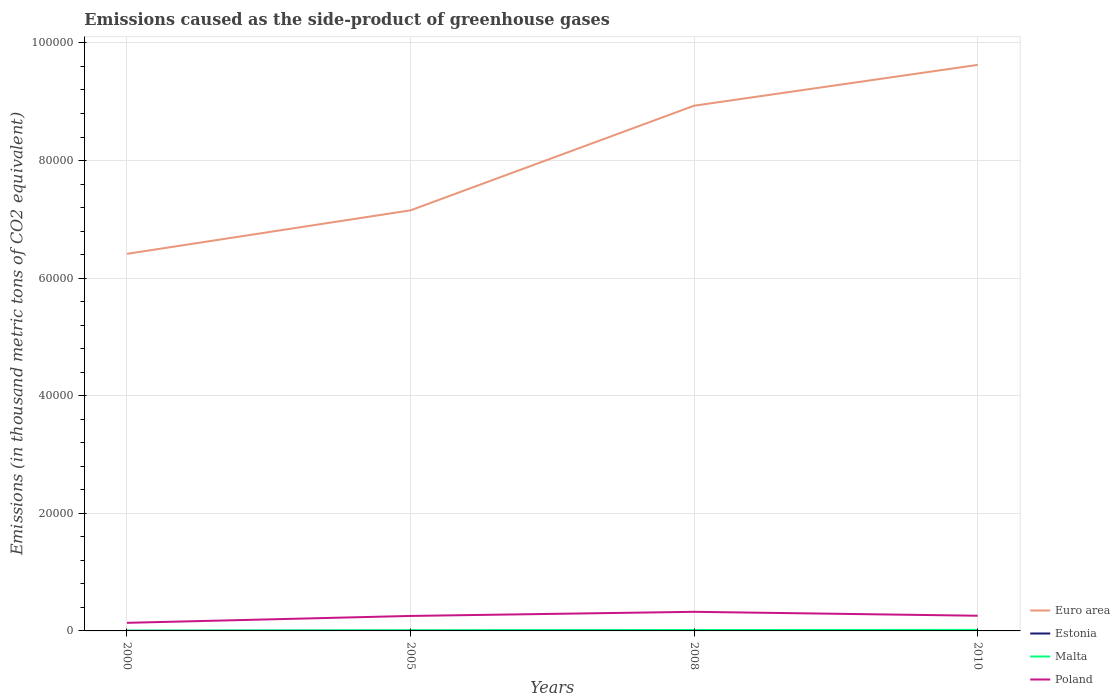How many different coloured lines are there?
Your answer should be very brief. 4. Does the line corresponding to Estonia intersect with the line corresponding to Malta?
Make the answer very short. No. Across all years, what is the maximum emissions caused as the side-product of greenhouse gases in Euro area?
Your answer should be very brief. 6.41e+04. What is the total emissions caused as the side-product of greenhouse gases in Estonia in the graph?
Your answer should be very brief. -13.9. What is the difference between the highest and the second highest emissions caused as the side-product of greenhouse gases in Malta?
Ensure brevity in your answer.  123. How many years are there in the graph?
Your response must be concise. 4. What is the difference between two consecutive major ticks on the Y-axis?
Provide a succinct answer. 2.00e+04. Are the values on the major ticks of Y-axis written in scientific E-notation?
Offer a terse response. No. Does the graph contain any zero values?
Give a very brief answer. No. Does the graph contain grids?
Your response must be concise. Yes. Where does the legend appear in the graph?
Ensure brevity in your answer.  Bottom right. How many legend labels are there?
Your response must be concise. 4. What is the title of the graph?
Provide a succinct answer. Emissions caused as the side-product of greenhouse gases. Does "Heavily indebted poor countries" appear as one of the legend labels in the graph?
Give a very brief answer. No. What is the label or title of the Y-axis?
Your response must be concise. Emissions (in thousand metric tons of CO2 equivalent). What is the Emissions (in thousand metric tons of CO2 equivalent) in Euro area in 2000?
Ensure brevity in your answer.  6.41e+04. What is the Emissions (in thousand metric tons of CO2 equivalent) of Poland in 2000?
Offer a terse response. 1376.3. What is the Emissions (in thousand metric tons of CO2 equivalent) of Euro area in 2005?
Your response must be concise. 7.15e+04. What is the Emissions (in thousand metric tons of CO2 equivalent) of Estonia in 2005?
Provide a short and direct response. 39.4. What is the Emissions (in thousand metric tons of CO2 equivalent) of Malta in 2005?
Offer a very short reply. 114.2. What is the Emissions (in thousand metric tons of CO2 equivalent) of Poland in 2005?
Ensure brevity in your answer.  2547.9. What is the Emissions (in thousand metric tons of CO2 equivalent) of Euro area in 2008?
Provide a short and direct response. 8.93e+04. What is the Emissions (in thousand metric tons of CO2 equivalent) in Estonia in 2008?
Your response must be concise. 53.3. What is the Emissions (in thousand metric tons of CO2 equivalent) of Malta in 2008?
Give a very brief answer. 153.2. What is the Emissions (in thousand metric tons of CO2 equivalent) in Poland in 2008?
Your answer should be compact. 3249.8. What is the Emissions (in thousand metric tons of CO2 equivalent) in Euro area in 2010?
Your response must be concise. 9.63e+04. What is the Emissions (in thousand metric tons of CO2 equivalent) of Malta in 2010?
Keep it short and to the point. 173. What is the Emissions (in thousand metric tons of CO2 equivalent) of Poland in 2010?
Offer a terse response. 2582. Across all years, what is the maximum Emissions (in thousand metric tons of CO2 equivalent) in Euro area?
Your answer should be compact. 9.63e+04. Across all years, what is the maximum Emissions (in thousand metric tons of CO2 equivalent) in Malta?
Ensure brevity in your answer.  173. Across all years, what is the maximum Emissions (in thousand metric tons of CO2 equivalent) in Poland?
Provide a succinct answer. 3249.8. Across all years, what is the minimum Emissions (in thousand metric tons of CO2 equivalent) of Euro area?
Your answer should be compact. 6.41e+04. Across all years, what is the minimum Emissions (in thousand metric tons of CO2 equivalent) of Estonia?
Make the answer very short. 13.3. Across all years, what is the minimum Emissions (in thousand metric tons of CO2 equivalent) of Malta?
Ensure brevity in your answer.  50. Across all years, what is the minimum Emissions (in thousand metric tons of CO2 equivalent) in Poland?
Make the answer very short. 1376.3. What is the total Emissions (in thousand metric tons of CO2 equivalent) of Euro area in the graph?
Give a very brief answer. 3.21e+05. What is the total Emissions (in thousand metric tons of CO2 equivalent) of Estonia in the graph?
Give a very brief answer. 169. What is the total Emissions (in thousand metric tons of CO2 equivalent) in Malta in the graph?
Keep it short and to the point. 490.4. What is the total Emissions (in thousand metric tons of CO2 equivalent) in Poland in the graph?
Provide a succinct answer. 9756. What is the difference between the Emissions (in thousand metric tons of CO2 equivalent) in Euro area in 2000 and that in 2005?
Ensure brevity in your answer.  -7401.3. What is the difference between the Emissions (in thousand metric tons of CO2 equivalent) in Estonia in 2000 and that in 2005?
Keep it short and to the point. -26.1. What is the difference between the Emissions (in thousand metric tons of CO2 equivalent) of Malta in 2000 and that in 2005?
Provide a succinct answer. -64.2. What is the difference between the Emissions (in thousand metric tons of CO2 equivalent) of Poland in 2000 and that in 2005?
Your answer should be compact. -1171.6. What is the difference between the Emissions (in thousand metric tons of CO2 equivalent) in Euro area in 2000 and that in 2008?
Your response must be concise. -2.52e+04. What is the difference between the Emissions (in thousand metric tons of CO2 equivalent) in Estonia in 2000 and that in 2008?
Keep it short and to the point. -40. What is the difference between the Emissions (in thousand metric tons of CO2 equivalent) in Malta in 2000 and that in 2008?
Ensure brevity in your answer.  -103.2. What is the difference between the Emissions (in thousand metric tons of CO2 equivalent) of Poland in 2000 and that in 2008?
Ensure brevity in your answer.  -1873.5. What is the difference between the Emissions (in thousand metric tons of CO2 equivalent) in Euro area in 2000 and that in 2010?
Provide a succinct answer. -3.21e+04. What is the difference between the Emissions (in thousand metric tons of CO2 equivalent) in Estonia in 2000 and that in 2010?
Ensure brevity in your answer.  -49.7. What is the difference between the Emissions (in thousand metric tons of CO2 equivalent) of Malta in 2000 and that in 2010?
Make the answer very short. -123. What is the difference between the Emissions (in thousand metric tons of CO2 equivalent) of Poland in 2000 and that in 2010?
Ensure brevity in your answer.  -1205.7. What is the difference between the Emissions (in thousand metric tons of CO2 equivalent) of Euro area in 2005 and that in 2008?
Make the answer very short. -1.78e+04. What is the difference between the Emissions (in thousand metric tons of CO2 equivalent) of Estonia in 2005 and that in 2008?
Keep it short and to the point. -13.9. What is the difference between the Emissions (in thousand metric tons of CO2 equivalent) of Malta in 2005 and that in 2008?
Provide a short and direct response. -39. What is the difference between the Emissions (in thousand metric tons of CO2 equivalent) in Poland in 2005 and that in 2008?
Offer a terse response. -701.9. What is the difference between the Emissions (in thousand metric tons of CO2 equivalent) of Euro area in 2005 and that in 2010?
Keep it short and to the point. -2.47e+04. What is the difference between the Emissions (in thousand metric tons of CO2 equivalent) of Estonia in 2005 and that in 2010?
Keep it short and to the point. -23.6. What is the difference between the Emissions (in thousand metric tons of CO2 equivalent) of Malta in 2005 and that in 2010?
Keep it short and to the point. -58.8. What is the difference between the Emissions (in thousand metric tons of CO2 equivalent) in Poland in 2005 and that in 2010?
Keep it short and to the point. -34.1. What is the difference between the Emissions (in thousand metric tons of CO2 equivalent) of Euro area in 2008 and that in 2010?
Ensure brevity in your answer.  -6944.7. What is the difference between the Emissions (in thousand metric tons of CO2 equivalent) of Malta in 2008 and that in 2010?
Make the answer very short. -19.8. What is the difference between the Emissions (in thousand metric tons of CO2 equivalent) of Poland in 2008 and that in 2010?
Provide a succinct answer. 667.8. What is the difference between the Emissions (in thousand metric tons of CO2 equivalent) in Euro area in 2000 and the Emissions (in thousand metric tons of CO2 equivalent) in Estonia in 2005?
Your response must be concise. 6.41e+04. What is the difference between the Emissions (in thousand metric tons of CO2 equivalent) in Euro area in 2000 and the Emissions (in thousand metric tons of CO2 equivalent) in Malta in 2005?
Your answer should be compact. 6.40e+04. What is the difference between the Emissions (in thousand metric tons of CO2 equivalent) in Euro area in 2000 and the Emissions (in thousand metric tons of CO2 equivalent) in Poland in 2005?
Your answer should be very brief. 6.16e+04. What is the difference between the Emissions (in thousand metric tons of CO2 equivalent) of Estonia in 2000 and the Emissions (in thousand metric tons of CO2 equivalent) of Malta in 2005?
Ensure brevity in your answer.  -100.9. What is the difference between the Emissions (in thousand metric tons of CO2 equivalent) in Estonia in 2000 and the Emissions (in thousand metric tons of CO2 equivalent) in Poland in 2005?
Make the answer very short. -2534.6. What is the difference between the Emissions (in thousand metric tons of CO2 equivalent) of Malta in 2000 and the Emissions (in thousand metric tons of CO2 equivalent) of Poland in 2005?
Offer a terse response. -2497.9. What is the difference between the Emissions (in thousand metric tons of CO2 equivalent) in Euro area in 2000 and the Emissions (in thousand metric tons of CO2 equivalent) in Estonia in 2008?
Keep it short and to the point. 6.41e+04. What is the difference between the Emissions (in thousand metric tons of CO2 equivalent) in Euro area in 2000 and the Emissions (in thousand metric tons of CO2 equivalent) in Malta in 2008?
Provide a succinct answer. 6.40e+04. What is the difference between the Emissions (in thousand metric tons of CO2 equivalent) of Euro area in 2000 and the Emissions (in thousand metric tons of CO2 equivalent) of Poland in 2008?
Ensure brevity in your answer.  6.09e+04. What is the difference between the Emissions (in thousand metric tons of CO2 equivalent) in Estonia in 2000 and the Emissions (in thousand metric tons of CO2 equivalent) in Malta in 2008?
Ensure brevity in your answer.  -139.9. What is the difference between the Emissions (in thousand metric tons of CO2 equivalent) in Estonia in 2000 and the Emissions (in thousand metric tons of CO2 equivalent) in Poland in 2008?
Ensure brevity in your answer.  -3236.5. What is the difference between the Emissions (in thousand metric tons of CO2 equivalent) in Malta in 2000 and the Emissions (in thousand metric tons of CO2 equivalent) in Poland in 2008?
Provide a succinct answer. -3199.8. What is the difference between the Emissions (in thousand metric tons of CO2 equivalent) in Euro area in 2000 and the Emissions (in thousand metric tons of CO2 equivalent) in Estonia in 2010?
Offer a very short reply. 6.41e+04. What is the difference between the Emissions (in thousand metric tons of CO2 equivalent) of Euro area in 2000 and the Emissions (in thousand metric tons of CO2 equivalent) of Malta in 2010?
Your response must be concise. 6.40e+04. What is the difference between the Emissions (in thousand metric tons of CO2 equivalent) in Euro area in 2000 and the Emissions (in thousand metric tons of CO2 equivalent) in Poland in 2010?
Your answer should be very brief. 6.15e+04. What is the difference between the Emissions (in thousand metric tons of CO2 equivalent) of Estonia in 2000 and the Emissions (in thousand metric tons of CO2 equivalent) of Malta in 2010?
Offer a very short reply. -159.7. What is the difference between the Emissions (in thousand metric tons of CO2 equivalent) in Estonia in 2000 and the Emissions (in thousand metric tons of CO2 equivalent) in Poland in 2010?
Make the answer very short. -2568.7. What is the difference between the Emissions (in thousand metric tons of CO2 equivalent) of Malta in 2000 and the Emissions (in thousand metric tons of CO2 equivalent) of Poland in 2010?
Provide a short and direct response. -2532. What is the difference between the Emissions (in thousand metric tons of CO2 equivalent) in Euro area in 2005 and the Emissions (in thousand metric tons of CO2 equivalent) in Estonia in 2008?
Keep it short and to the point. 7.15e+04. What is the difference between the Emissions (in thousand metric tons of CO2 equivalent) in Euro area in 2005 and the Emissions (in thousand metric tons of CO2 equivalent) in Malta in 2008?
Ensure brevity in your answer.  7.14e+04. What is the difference between the Emissions (in thousand metric tons of CO2 equivalent) of Euro area in 2005 and the Emissions (in thousand metric tons of CO2 equivalent) of Poland in 2008?
Provide a short and direct response. 6.83e+04. What is the difference between the Emissions (in thousand metric tons of CO2 equivalent) of Estonia in 2005 and the Emissions (in thousand metric tons of CO2 equivalent) of Malta in 2008?
Keep it short and to the point. -113.8. What is the difference between the Emissions (in thousand metric tons of CO2 equivalent) in Estonia in 2005 and the Emissions (in thousand metric tons of CO2 equivalent) in Poland in 2008?
Offer a terse response. -3210.4. What is the difference between the Emissions (in thousand metric tons of CO2 equivalent) of Malta in 2005 and the Emissions (in thousand metric tons of CO2 equivalent) of Poland in 2008?
Offer a terse response. -3135.6. What is the difference between the Emissions (in thousand metric tons of CO2 equivalent) in Euro area in 2005 and the Emissions (in thousand metric tons of CO2 equivalent) in Estonia in 2010?
Ensure brevity in your answer.  7.15e+04. What is the difference between the Emissions (in thousand metric tons of CO2 equivalent) in Euro area in 2005 and the Emissions (in thousand metric tons of CO2 equivalent) in Malta in 2010?
Provide a succinct answer. 7.14e+04. What is the difference between the Emissions (in thousand metric tons of CO2 equivalent) in Euro area in 2005 and the Emissions (in thousand metric tons of CO2 equivalent) in Poland in 2010?
Provide a succinct answer. 6.89e+04. What is the difference between the Emissions (in thousand metric tons of CO2 equivalent) of Estonia in 2005 and the Emissions (in thousand metric tons of CO2 equivalent) of Malta in 2010?
Offer a very short reply. -133.6. What is the difference between the Emissions (in thousand metric tons of CO2 equivalent) of Estonia in 2005 and the Emissions (in thousand metric tons of CO2 equivalent) of Poland in 2010?
Your answer should be compact. -2542.6. What is the difference between the Emissions (in thousand metric tons of CO2 equivalent) in Malta in 2005 and the Emissions (in thousand metric tons of CO2 equivalent) in Poland in 2010?
Offer a terse response. -2467.8. What is the difference between the Emissions (in thousand metric tons of CO2 equivalent) of Euro area in 2008 and the Emissions (in thousand metric tons of CO2 equivalent) of Estonia in 2010?
Offer a very short reply. 8.93e+04. What is the difference between the Emissions (in thousand metric tons of CO2 equivalent) of Euro area in 2008 and the Emissions (in thousand metric tons of CO2 equivalent) of Malta in 2010?
Provide a succinct answer. 8.92e+04. What is the difference between the Emissions (in thousand metric tons of CO2 equivalent) in Euro area in 2008 and the Emissions (in thousand metric tons of CO2 equivalent) in Poland in 2010?
Provide a succinct answer. 8.67e+04. What is the difference between the Emissions (in thousand metric tons of CO2 equivalent) of Estonia in 2008 and the Emissions (in thousand metric tons of CO2 equivalent) of Malta in 2010?
Provide a succinct answer. -119.7. What is the difference between the Emissions (in thousand metric tons of CO2 equivalent) of Estonia in 2008 and the Emissions (in thousand metric tons of CO2 equivalent) of Poland in 2010?
Provide a succinct answer. -2528.7. What is the difference between the Emissions (in thousand metric tons of CO2 equivalent) of Malta in 2008 and the Emissions (in thousand metric tons of CO2 equivalent) of Poland in 2010?
Ensure brevity in your answer.  -2428.8. What is the average Emissions (in thousand metric tons of CO2 equivalent) of Euro area per year?
Offer a very short reply. 8.03e+04. What is the average Emissions (in thousand metric tons of CO2 equivalent) of Estonia per year?
Give a very brief answer. 42.25. What is the average Emissions (in thousand metric tons of CO2 equivalent) in Malta per year?
Give a very brief answer. 122.6. What is the average Emissions (in thousand metric tons of CO2 equivalent) of Poland per year?
Give a very brief answer. 2439. In the year 2000, what is the difference between the Emissions (in thousand metric tons of CO2 equivalent) of Euro area and Emissions (in thousand metric tons of CO2 equivalent) of Estonia?
Your answer should be very brief. 6.41e+04. In the year 2000, what is the difference between the Emissions (in thousand metric tons of CO2 equivalent) in Euro area and Emissions (in thousand metric tons of CO2 equivalent) in Malta?
Provide a succinct answer. 6.41e+04. In the year 2000, what is the difference between the Emissions (in thousand metric tons of CO2 equivalent) in Euro area and Emissions (in thousand metric tons of CO2 equivalent) in Poland?
Ensure brevity in your answer.  6.28e+04. In the year 2000, what is the difference between the Emissions (in thousand metric tons of CO2 equivalent) of Estonia and Emissions (in thousand metric tons of CO2 equivalent) of Malta?
Your answer should be compact. -36.7. In the year 2000, what is the difference between the Emissions (in thousand metric tons of CO2 equivalent) in Estonia and Emissions (in thousand metric tons of CO2 equivalent) in Poland?
Your answer should be very brief. -1363. In the year 2000, what is the difference between the Emissions (in thousand metric tons of CO2 equivalent) of Malta and Emissions (in thousand metric tons of CO2 equivalent) of Poland?
Keep it short and to the point. -1326.3. In the year 2005, what is the difference between the Emissions (in thousand metric tons of CO2 equivalent) of Euro area and Emissions (in thousand metric tons of CO2 equivalent) of Estonia?
Make the answer very short. 7.15e+04. In the year 2005, what is the difference between the Emissions (in thousand metric tons of CO2 equivalent) of Euro area and Emissions (in thousand metric tons of CO2 equivalent) of Malta?
Your answer should be compact. 7.14e+04. In the year 2005, what is the difference between the Emissions (in thousand metric tons of CO2 equivalent) in Euro area and Emissions (in thousand metric tons of CO2 equivalent) in Poland?
Your response must be concise. 6.90e+04. In the year 2005, what is the difference between the Emissions (in thousand metric tons of CO2 equivalent) of Estonia and Emissions (in thousand metric tons of CO2 equivalent) of Malta?
Offer a terse response. -74.8. In the year 2005, what is the difference between the Emissions (in thousand metric tons of CO2 equivalent) in Estonia and Emissions (in thousand metric tons of CO2 equivalent) in Poland?
Offer a terse response. -2508.5. In the year 2005, what is the difference between the Emissions (in thousand metric tons of CO2 equivalent) of Malta and Emissions (in thousand metric tons of CO2 equivalent) of Poland?
Provide a short and direct response. -2433.7. In the year 2008, what is the difference between the Emissions (in thousand metric tons of CO2 equivalent) in Euro area and Emissions (in thousand metric tons of CO2 equivalent) in Estonia?
Your answer should be compact. 8.93e+04. In the year 2008, what is the difference between the Emissions (in thousand metric tons of CO2 equivalent) in Euro area and Emissions (in thousand metric tons of CO2 equivalent) in Malta?
Keep it short and to the point. 8.92e+04. In the year 2008, what is the difference between the Emissions (in thousand metric tons of CO2 equivalent) in Euro area and Emissions (in thousand metric tons of CO2 equivalent) in Poland?
Offer a very short reply. 8.61e+04. In the year 2008, what is the difference between the Emissions (in thousand metric tons of CO2 equivalent) in Estonia and Emissions (in thousand metric tons of CO2 equivalent) in Malta?
Ensure brevity in your answer.  -99.9. In the year 2008, what is the difference between the Emissions (in thousand metric tons of CO2 equivalent) in Estonia and Emissions (in thousand metric tons of CO2 equivalent) in Poland?
Make the answer very short. -3196.5. In the year 2008, what is the difference between the Emissions (in thousand metric tons of CO2 equivalent) in Malta and Emissions (in thousand metric tons of CO2 equivalent) in Poland?
Provide a short and direct response. -3096.6. In the year 2010, what is the difference between the Emissions (in thousand metric tons of CO2 equivalent) of Euro area and Emissions (in thousand metric tons of CO2 equivalent) of Estonia?
Ensure brevity in your answer.  9.62e+04. In the year 2010, what is the difference between the Emissions (in thousand metric tons of CO2 equivalent) in Euro area and Emissions (in thousand metric tons of CO2 equivalent) in Malta?
Your answer should be compact. 9.61e+04. In the year 2010, what is the difference between the Emissions (in thousand metric tons of CO2 equivalent) in Euro area and Emissions (in thousand metric tons of CO2 equivalent) in Poland?
Keep it short and to the point. 9.37e+04. In the year 2010, what is the difference between the Emissions (in thousand metric tons of CO2 equivalent) of Estonia and Emissions (in thousand metric tons of CO2 equivalent) of Malta?
Ensure brevity in your answer.  -110. In the year 2010, what is the difference between the Emissions (in thousand metric tons of CO2 equivalent) in Estonia and Emissions (in thousand metric tons of CO2 equivalent) in Poland?
Make the answer very short. -2519. In the year 2010, what is the difference between the Emissions (in thousand metric tons of CO2 equivalent) in Malta and Emissions (in thousand metric tons of CO2 equivalent) in Poland?
Provide a succinct answer. -2409. What is the ratio of the Emissions (in thousand metric tons of CO2 equivalent) of Euro area in 2000 to that in 2005?
Your response must be concise. 0.9. What is the ratio of the Emissions (in thousand metric tons of CO2 equivalent) in Estonia in 2000 to that in 2005?
Offer a very short reply. 0.34. What is the ratio of the Emissions (in thousand metric tons of CO2 equivalent) in Malta in 2000 to that in 2005?
Keep it short and to the point. 0.44. What is the ratio of the Emissions (in thousand metric tons of CO2 equivalent) of Poland in 2000 to that in 2005?
Ensure brevity in your answer.  0.54. What is the ratio of the Emissions (in thousand metric tons of CO2 equivalent) in Euro area in 2000 to that in 2008?
Offer a very short reply. 0.72. What is the ratio of the Emissions (in thousand metric tons of CO2 equivalent) of Estonia in 2000 to that in 2008?
Give a very brief answer. 0.25. What is the ratio of the Emissions (in thousand metric tons of CO2 equivalent) of Malta in 2000 to that in 2008?
Your answer should be very brief. 0.33. What is the ratio of the Emissions (in thousand metric tons of CO2 equivalent) in Poland in 2000 to that in 2008?
Your answer should be compact. 0.42. What is the ratio of the Emissions (in thousand metric tons of CO2 equivalent) of Euro area in 2000 to that in 2010?
Provide a succinct answer. 0.67. What is the ratio of the Emissions (in thousand metric tons of CO2 equivalent) of Estonia in 2000 to that in 2010?
Keep it short and to the point. 0.21. What is the ratio of the Emissions (in thousand metric tons of CO2 equivalent) in Malta in 2000 to that in 2010?
Give a very brief answer. 0.29. What is the ratio of the Emissions (in thousand metric tons of CO2 equivalent) in Poland in 2000 to that in 2010?
Keep it short and to the point. 0.53. What is the ratio of the Emissions (in thousand metric tons of CO2 equivalent) in Euro area in 2005 to that in 2008?
Your answer should be very brief. 0.8. What is the ratio of the Emissions (in thousand metric tons of CO2 equivalent) in Estonia in 2005 to that in 2008?
Your response must be concise. 0.74. What is the ratio of the Emissions (in thousand metric tons of CO2 equivalent) in Malta in 2005 to that in 2008?
Provide a short and direct response. 0.75. What is the ratio of the Emissions (in thousand metric tons of CO2 equivalent) of Poland in 2005 to that in 2008?
Offer a very short reply. 0.78. What is the ratio of the Emissions (in thousand metric tons of CO2 equivalent) in Euro area in 2005 to that in 2010?
Your answer should be very brief. 0.74. What is the ratio of the Emissions (in thousand metric tons of CO2 equivalent) of Estonia in 2005 to that in 2010?
Ensure brevity in your answer.  0.63. What is the ratio of the Emissions (in thousand metric tons of CO2 equivalent) of Malta in 2005 to that in 2010?
Provide a short and direct response. 0.66. What is the ratio of the Emissions (in thousand metric tons of CO2 equivalent) in Poland in 2005 to that in 2010?
Keep it short and to the point. 0.99. What is the ratio of the Emissions (in thousand metric tons of CO2 equivalent) in Euro area in 2008 to that in 2010?
Your response must be concise. 0.93. What is the ratio of the Emissions (in thousand metric tons of CO2 equivalent) of Estonia in 2008 to that in 2010?
Provide a succinct answer. 0.85. What is the ratio of the Emissions (in thousand metric tons of CO2 equivalent) in Malta in 2008 to that in 2010?
Make the answer very short. 0.89. What is the ratio of the Emissions (in thousand metric tons of CO2 equivalent) in Poland in 2008 to that in 2010?
Your response must be concise. 1.26. What is the difference between the highest and the second highest Emissions (in thousand metric tons of CO2 equivalent) of Euro area?
Provide a succinct answer. 6944.7. What is the difference between the highest and the second highest Emissions (in thousand metric tons of CO2 equivalent) of Estonia?
Your answer should be compact. 9.7. What is the difference between the highest and the second highest Emissions (in thousand metric tons of CO2 equivalent) of Malta?
Provide a short and direct response. 19.8. What is the difference between the highest and the second highest Emissions (in thousand metric tons of CO2 equivalent) of Poland?
Give a very brief answer. 667.8. What is the difference between the highest and the lowest Emissions (in thousand metric tons of CO2 equivalent) of Euro area?
Your response must be concise. 3.21e+04. What is the difference between the highest and the lowest Emissions (in thousand metric tons of CO2 equivalent) in Estonia?
Provide a short and direct response. 49.7. What is the difference between the highest and the lowest Emissions (in thousand metric tons of CO2 equivalent) in Malta?
Your answer should be compact. 123. What is the difference between the highest and the lowest Emissions (in thousand metric tons of CO2 equivalent) in Poland?
Make the answer very short. 1873.5. 